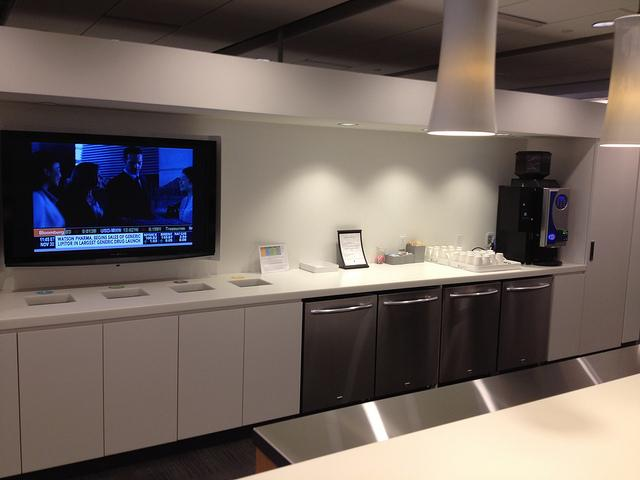What station is on the television? bloomberg 